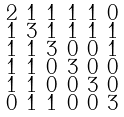<formula> <loc_0><loc_0><loc_500><loc_500>\begin{smallmatrix} 2 & 1 & 1 & 1 & 1 & 0 \\ 1 & 3 & 1 & 1 & 1 & 1 \\ 1 & 1 & 3 & 0 & 0 & 1 \\ 1 & 1 & 0 & 3 & 0 & 0 \\ 1 & 1 & 0 & 0 & 3 & 0 \\ 0 & 1 & 1 & 0 & 0 & 3 \end{smallmatrix}</formula> 